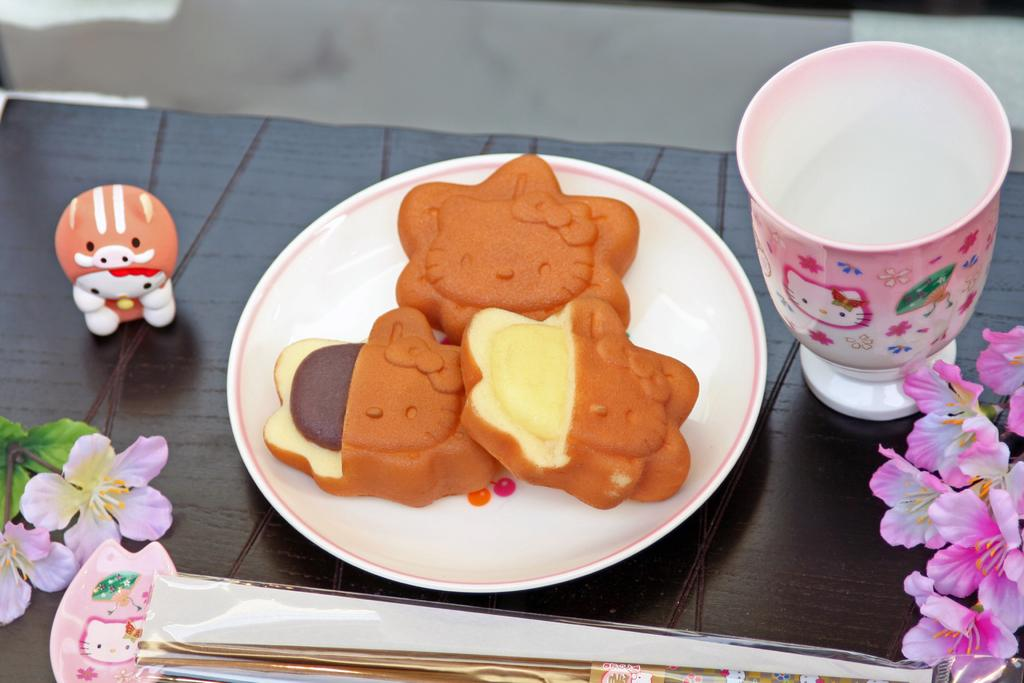What is placed on the plate in the image? There are eatables placed in a plate in the image. Where is the plate located? The plate is on a table in the image. What is the cup used for in the image? The cup is likely used for holding a beverage. What type of decorative elements can be seen in the image? There are flowers in the image. Can you describe any other objects present in the image? There are other objects present in the image, but their specific details are not mentioned in the provided facts. What is the outcome of the competition taking place in the image? There is no competition present in the image, so it is not possible to determine the outcome. 